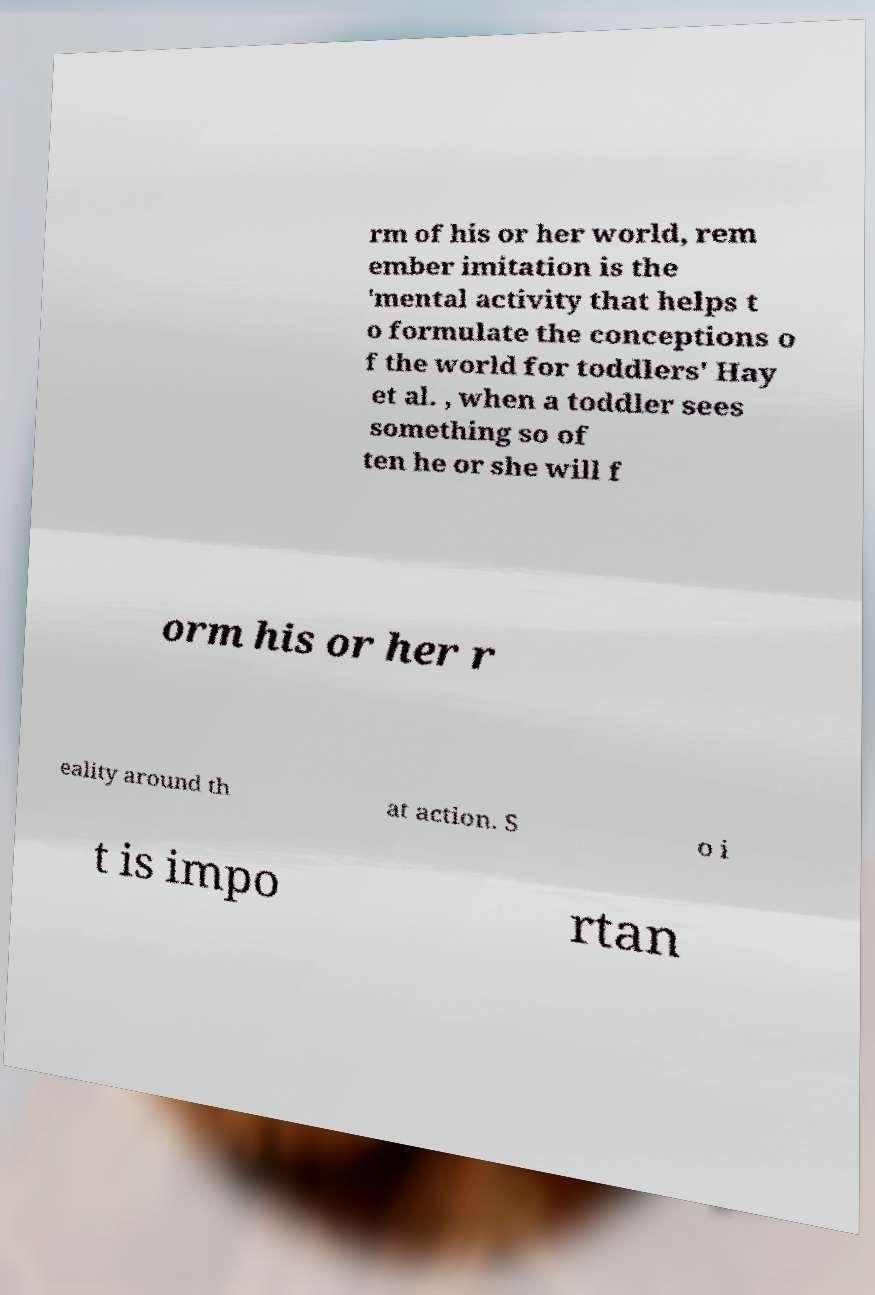Could you assist in decoding the text presented in this image and type it out clearly? rm of his or her world, rem ember imitation is the 'mental activity that helps t o formulate the conceptions o f the world for toddlers' Hay et al. , when a toddler sees something so of ten he or she will f orm his or her r eality around th at action. S o i t is impo rtan 